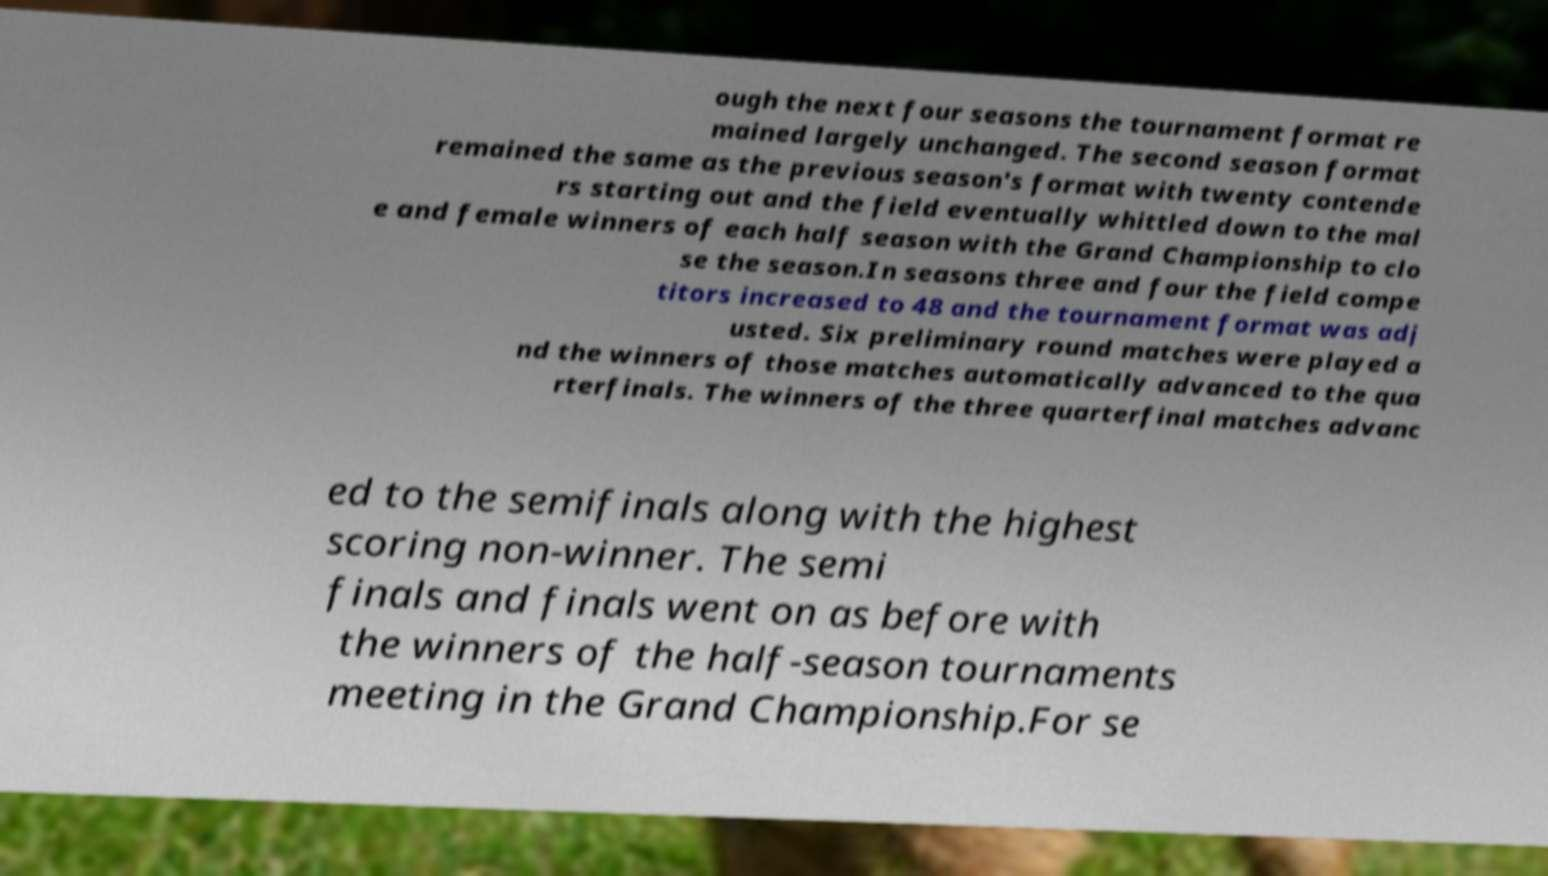What messages or text are displayed in this image? I need them in a readable, typed format. ough the next four seasons the tournament format re mained largely unchanged. The second season format remained the same as the previous season's format with twenty contende rs starting out and the field eventually whittled down to the mal e and female winners of each half season with the Grand Championship to clo se the season.In seasons three and four the field compe titors increased to 48 and the tournament format was adj usted. Six preliminary round matches were played a nd the winners of those matches automatically advanced to the qua rterfinals. The winners of the three quarterfinal matches advanc ed to the semifinals along with the highest scoring non-winner. The semi finals and finals went on as before with the winners of the half-season tournaments meeting in the Grand Championship.For se 